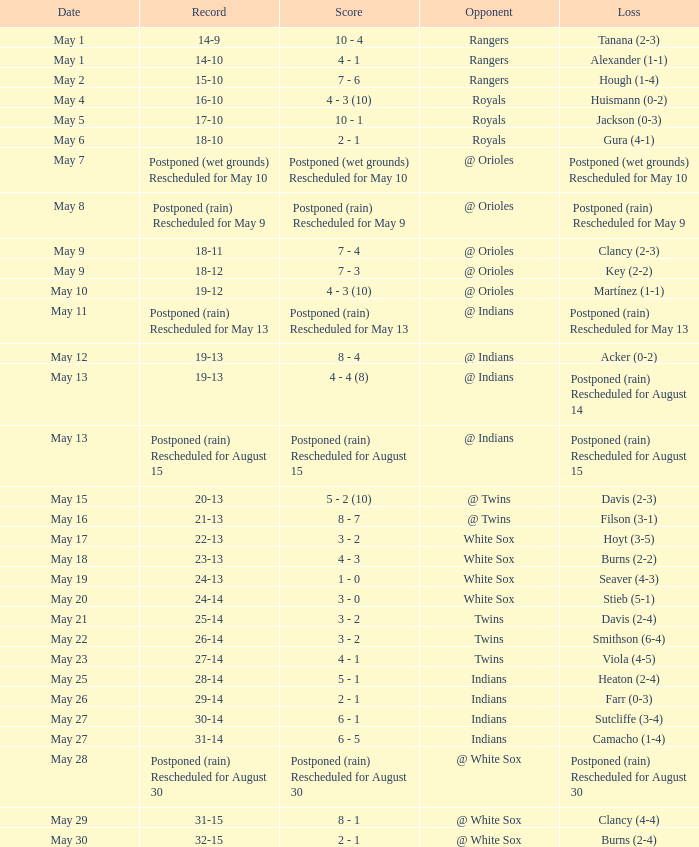What was the loss of the game when the record was 21-13? Filson (3-1). Give me the full table as a dictionary. {'header': ['Date', 'Record', 'Score', 'Opponent', 'Loss'], 'rows': [['May 1', '14-9', '10 - 4', 'Rangers', 'Tanana (2-3)'], ['May 1', '14-10', '4 - 1', 'Rangers', 'Alexander (1-1)'], ['May 2', '15-10', '7 - 6', 'Rangers', 'Hough (1-4)'], ['May 4', '16-10', '4 - 3 (10)', 'Royals', 'Huismann (0-2)'], ['May 5', '17-10', '10 - 1', 'Royals', 'Jackson (0-3)'], ['May 6', '18-10', '2 - 1', 'Royals', 'Gura (4-1)'], ['May 7', 'Postponed (wet grounds) Rescheduled for May 10', 'Postponed (wet grounds) Rescheduled for May 10', '@ Orioles', 'Postponed (wet grounds) Rescheduled for May 10'], ['May 8', 'Postponed (rain) Rescheduled for May 9', 'Postponed (rain) Rescheduled for May 9', '@ Orioles', 'Postponed (rain) Rescheduled for May 9'], ['May 9', '18-11', '7 - 4', '@ Orioles', 'Clancy (2-3)'], ['May 9', '18-12', '7 - 3', '@ Orioles', 'Key (2-2)'], ['May 10', '19-12', '4 - 3 (10)', '@ Orioles', 'Martínez (1-1)'], ['May 11', 'Postponed (rain) Rescheduled for May 13', 'Postponed (rain) Rescheduled for May 13', '@ Indians', 'Postponed (rain) Rescheduled for May 13'], ['May 12', '19-13', '8 - 4', '@ Indians', 'Acker (0-2)'], ['May 13', '19-13', '4 - 4 (8)', '@ Indians', 'Postponed (rain) Rescheduled for August 14'], ['May 13', 'Postponed (rain) Rescheduled for August 15', 'Postponed (rain) Rescheduled for August 15', '@ Indians', 'Postponed (rain) Rescheduled for August 15'], ['May 15', '20-13', '5 - 2 (10)', '@ Twins', 'Davis (2-3)'], ['May 16', '21-13', '8 - 7', '@ Twins', 'Filson (3-1)'], ['May 17', '22-13', '3 - 2', 'White Sox', 'Hoyt (3-5)'], ['May 18', '23-13', '4 - 3', 'White Sox', 'Burns (2-2)'], ['May 19', '24-13', '1 - 0', 'White Sox', 'Seaver (4-3)'], ['May 20', '24-14', '3 - 0', 'White Sox', 'Stieb (5-1)'], ['May 21', '25-14', '3 - 2', 'Twins', 'Davis (2-4)'], ['May 22', '26-14', '3 - 2', 'Twins', 'Smithson (6-4)'], ['May 23', '27-14', '4 - 1', 'Twins', 'Viola (4-5)'], ['May 25', '28-14', '5 - 1', 'Indians', 'Heaton (2-4)'], ['May 26', '29-14', '2 - 1', 'Indians', 'Farr (0-3)'], ['May 27', '30-14', '6 - 1', 'Indians', 'Sutcliffe (3-4)'], ['May 27', '31-14', '6 - 5', 'Indians', 'Camacho (1-4)'], ['May 28', 'Postponed (rain) Rescheduled for August 30', 'Postponed (rain) Rescheduled for August 30', '@ White Sox', 'Postponed (rain) Rescheduled for August 30'], ['May 29', '31-15', '8 - 1', '@ White Sox', 'Clancy (4-4)'], ['May 30', '32-15', '2 - 1', '@ White Sox', 'Burns (2-4)']]} 